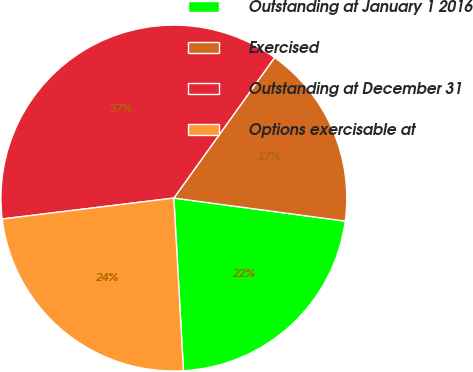<chart> <loc_0><loc_0><loc_500><loc_500><pie_chart><fcel>Outstanding at January 1 2016<fcel>Exercised<fcel>Outstanding at December 31<fcel>Options exercisable at<nl><fcel>21.99%<fcel>17.23%<fcel>36.83%<fcel>23.95%<nl></chart> 